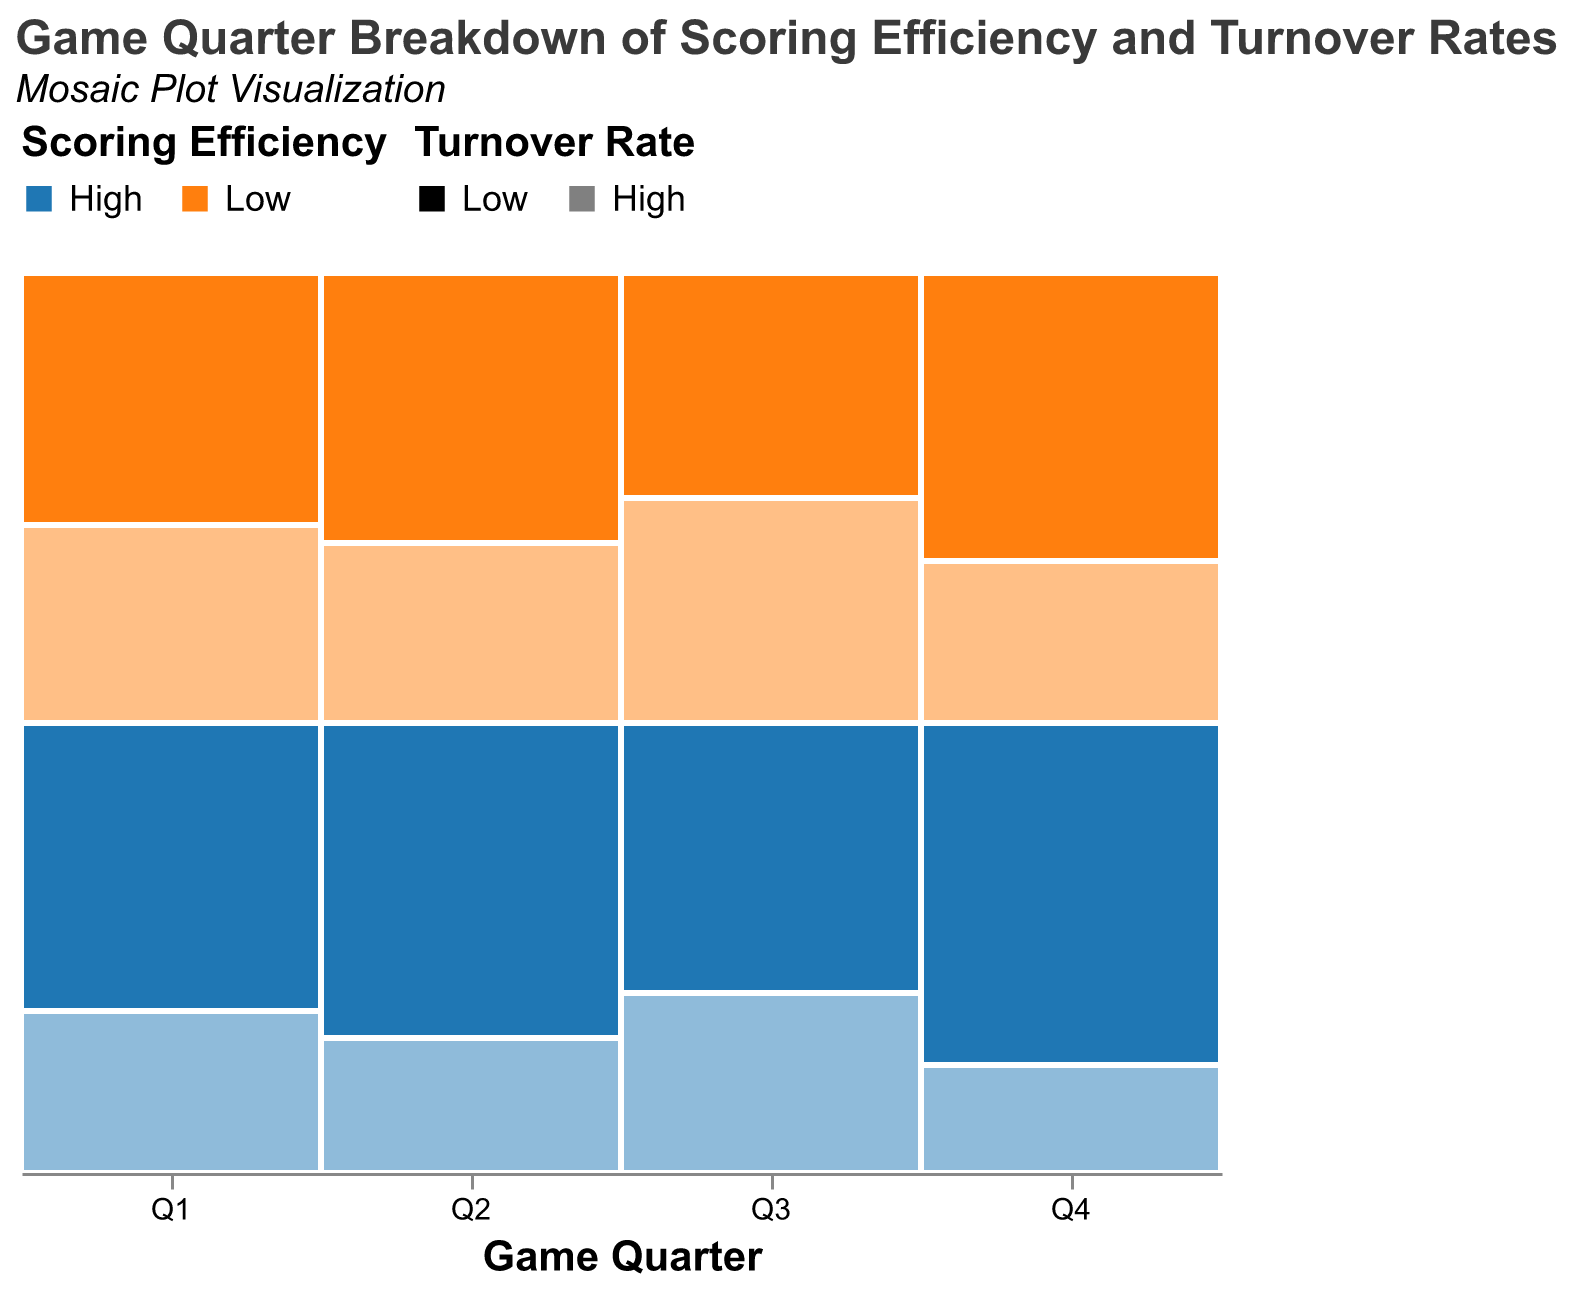What's the title of the figure? The title is usually located at the top of the figure, it reads "Game Quarter Breakdown of Scoring Efficiency and Turnover Rates".
Answer: Game Quarter Breakdown of Scoring Efficiency and Turnover Rates Which quarter has the highest frequency for "High" Scoring Efficiency and "Low" Turnover Rate? By observing the segments with "High" Scoring Efficiency (blue color) and "Low" Turnover Rate (less transparent), we see that Q4 has the tallest segment for this category.
Answer: Q4 What is the proportion of "Low" Scoring Efficiency and "High" Turnover Rate in Q1? The "Low" Scoring Efficiency (orange color) and "High" Turnover Rate (more transparent) segment in Q1 occupies a portion of the total height. It looks approximately like 22/(32+18+28+22)=22/100, which is 0.22.
Answer: 0.22 Compare the proportions of "High" Scoring Efficiency and "High" Turnover Rate between Q2 and Q3. Which quarter has a higher proportion for this category? The "High" Scoring Efficiency (blue color) and "High" Turnover Rate (more transparent) segment in Q2 takes up less space compared to the same segment in Q3. Thus, Q3 has a higher proportion.
Answer: Q3 How does the overall height distribution of "High" Scoring Efficiency compare between different quarters? Observing the height of the blue segments across all quarters, Q2 and Q4 have the tallest combined heights, showing that these quarters generally have higher scoring efficiency. Q1 and Q3 are comparatively shorter.
Answer: Q2 and Q4 show higher distribution Which quarter shows the least amount of "Low" Scoring Efficiency and "Low" Turnover Rate? By looking at the orange segment with less transparency, Q3 has the smallest portion height for "Low" Scoring Efficiency and "Low" Turnover Rate.
Answer: Q3 What can be inferred about the relationship between Scoring Efficiency and Turnover Rate in Q4? In Q4, observe the wide blue segment (High Scoring Efficiency) and how the less transparent portion (Low Turnover Rate) is larger in comparison to the more transparent portion. This indicates a higher proportion of efficient scoring with low turnovers in Q4.
Answer: High Scoring Efficiency correlates with Low Turnover Rate What's the combined frequency of both "High" and "Low" Scoring Efficiency with "High" Turnover Rate in Q3? In Q3, add the segments with "High" Turnover Rate: "High" Scoring Efficiency (20) and "Low" Scoring Efficiency (25), resulting in 20+25=45.
Answer: 45 How does the representation of "High" Turnover Rates change across the quarters? Observing the more transparent sections throughout the quarters, the distribution of "High" Turnover Rates appears fairly consistent across all quarters, with no quarter significantly standing out.
Answer: Fairly consistent across quarters Which quarter has the highest total frequency? By comparing the overall heights (sum of all segments) across quarters, Q4 has the greatest total height, indicating the highest frequency.
Answer: Q4 